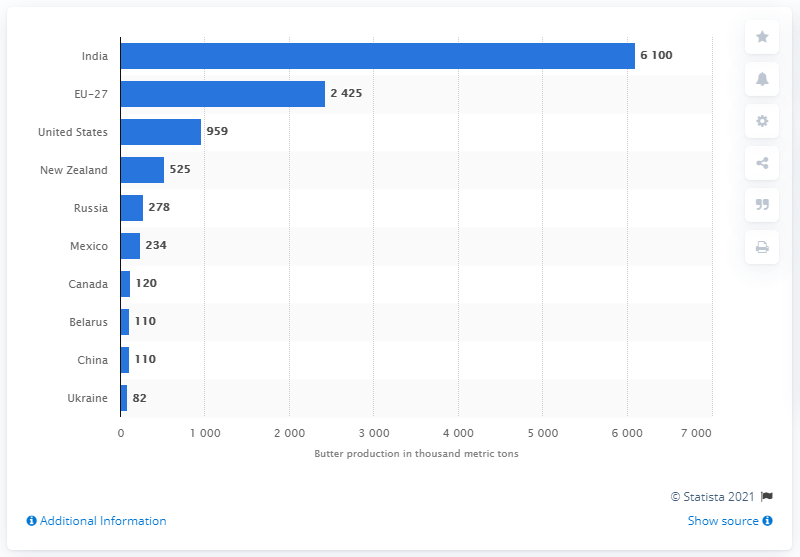Give some essential details in this illustration. According to the statistics from 2020, India was the country with the highest production of butter. 